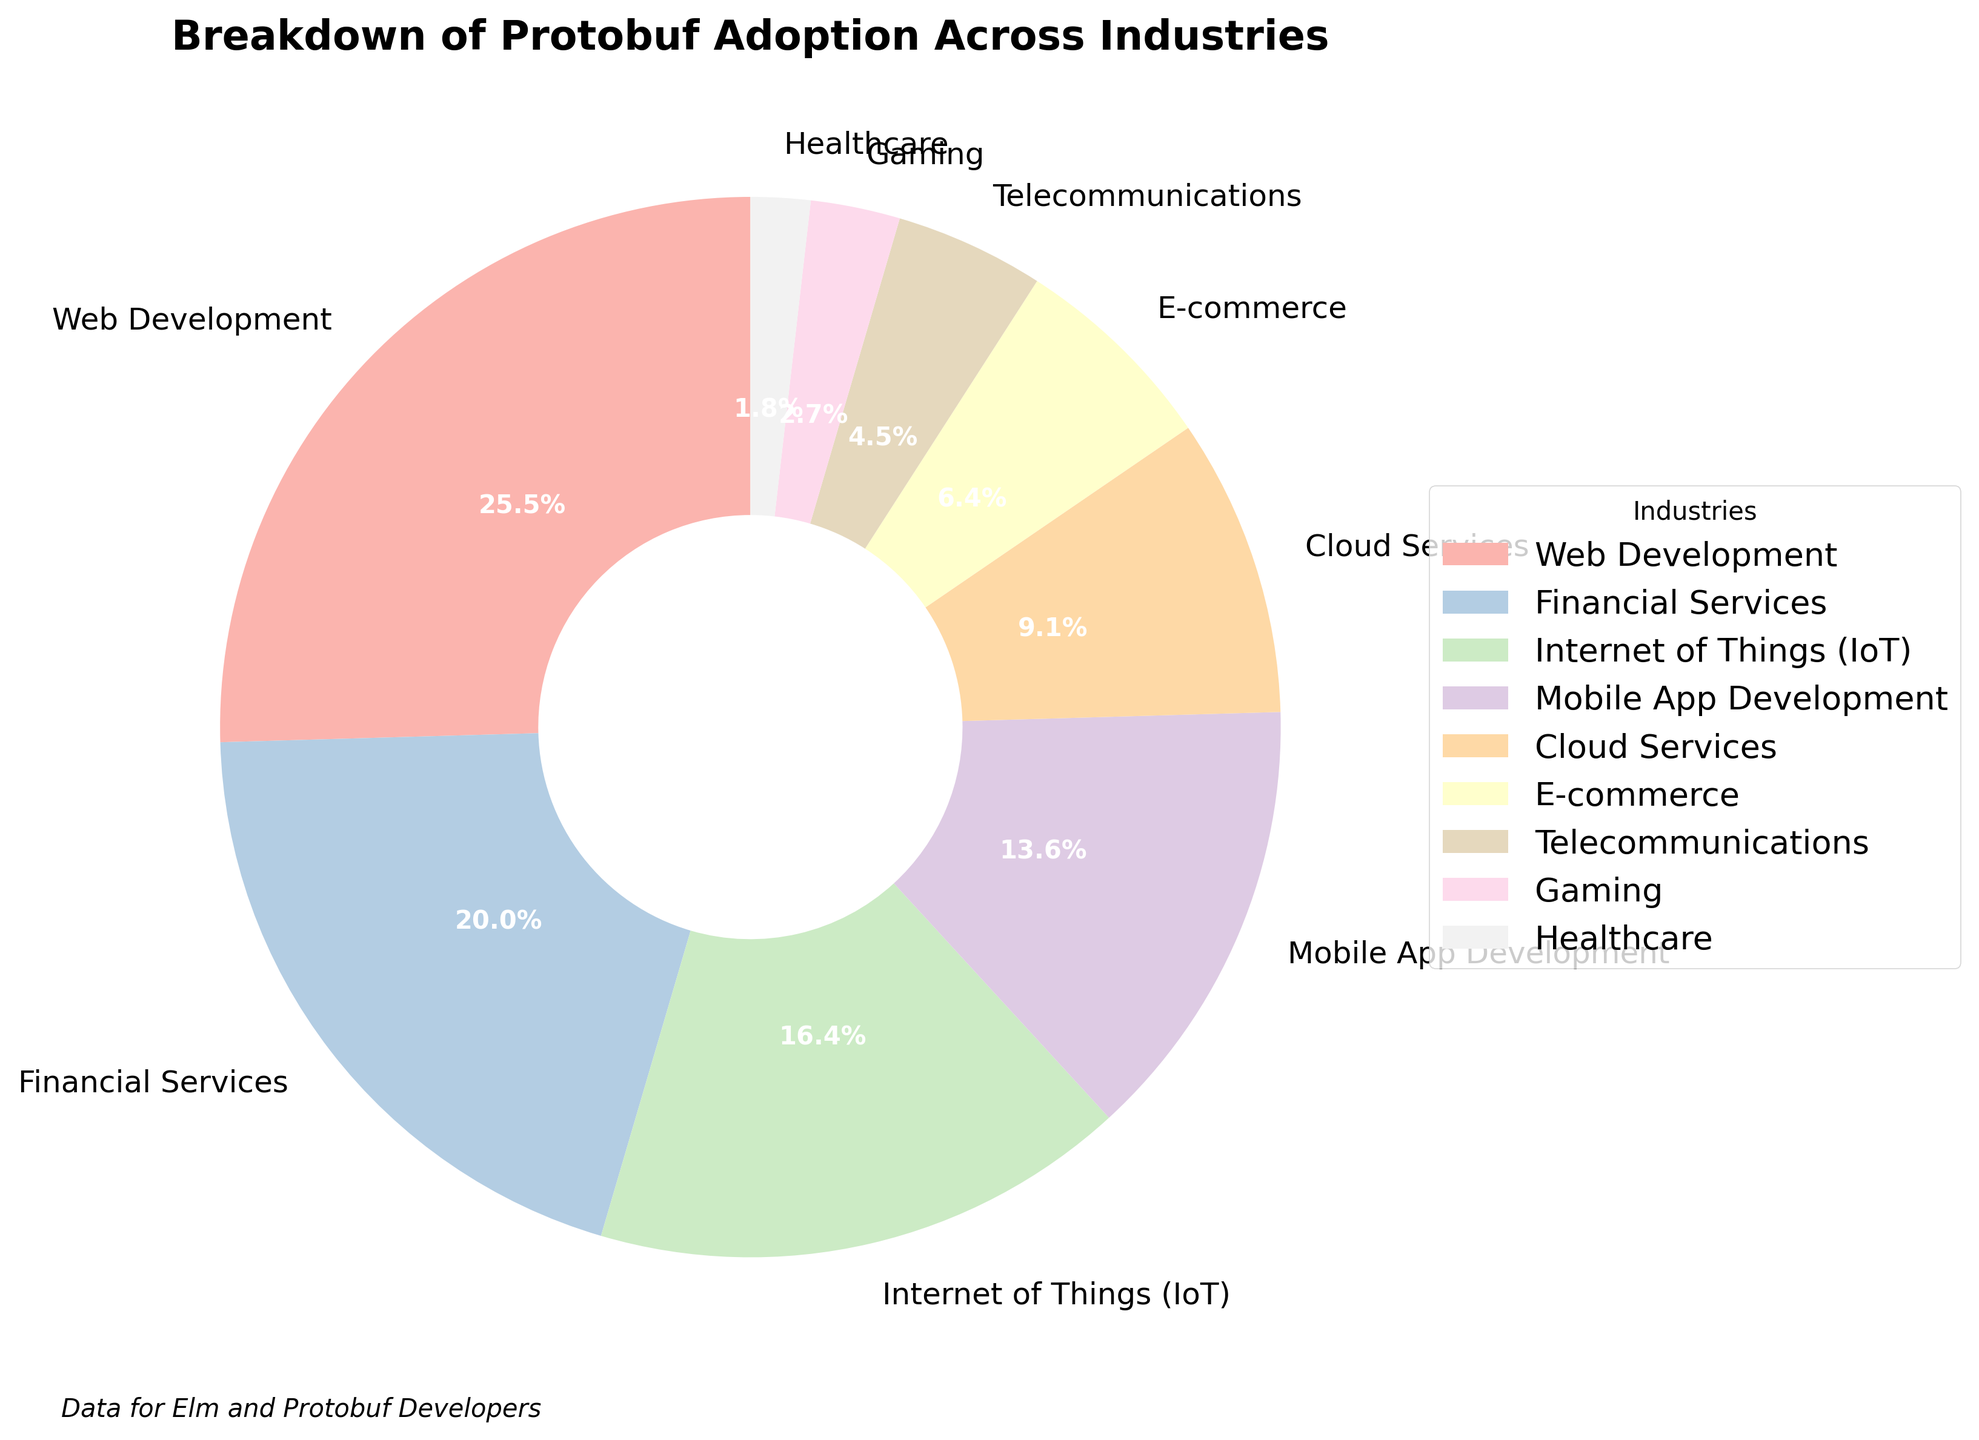Which industry has the highest adoption percentage of Protobuf? The industry with the highest adoption percentage will be the one with the largest segment in the pie chart. By looking at the chart, it is clear from the label and size of the segment that Web Development has the highest percentage.
Answer: Web Development Which industry has the smallest adoption percentage of Protobuf? The industry with the smallest adoption percentage will be represented by the smallest segment in the pie chart. The smallest segment in the chart corresponds to Healthcare.
Answer: Healthcare What is the total adoption percentage of Protobuf for Financial Services and Cloud Services combined? Add the percentages of the Financial Services segment (22%) and the Cloud Services segment (10%). So, 22% + 10% = 32%.
Answer: 32% How much greater is the adoption percentage of Web Development compared to Gaming? Subtract the adoption percentage of Gaming (3%) from Web Development (28%). So, 28% - 3% = 25%.
Answer: 25% Compare the adoption percentages of Mobile App Development and E-commerce. Which one is higher and by how much? Compare the percentages of Mobile App Development (15%) and E-commerce (7%). Mobile App Development is higher. Subtract 7% from 15% to find the difference. So, 15% - 7% = 8%.
Answer: Mobile App Development by 8% What is the total combined adoption percentage for the industries that make up less than 10% each? Sum the percentages of the segments representing less than 10%: E-commerce (7%), Telecommunications (5%), Gaming (3%), and Healthcare (2%). So, 7% + 5% + 3% + 2% = 17%.
Answer: 17% What is the average adoption percentage of Cloud Services, Telecommunications, and Gaming? Add the percentages of Cloud Services (10%), Telecommunications (5%), and Gaming (3%) and divide by 3. So, (10% + 5% + 3%) / 3 = 18% / 3 = 6%.
Answer: 6% Does Internet of Things (IoT) or Financial Services have a higher adoption percentage? Compare the percentages of Internet of Things (18%) and Financial Services (22%). Financial Services has a higher percentage.
Answer: Financial Services Among Cloud Services, E-commerce, and Telecommunications, which has the highest adoption percentage? Compare the percentages of Cloud Services (10%), E-commerce (7%), and Telecommunications (5%). Cloud Services has the highest percentage among them.
Answer: Cloud Services What is the difference in adoption percentage between the two industries with the highest and lowest adoption? Identify the highest (Web Development, 28%) and lowest (Healthcare, 2%) adoption percentages. Subtract the lowest from the highest: 28% - 2% = 26%.
Answer: 26% 